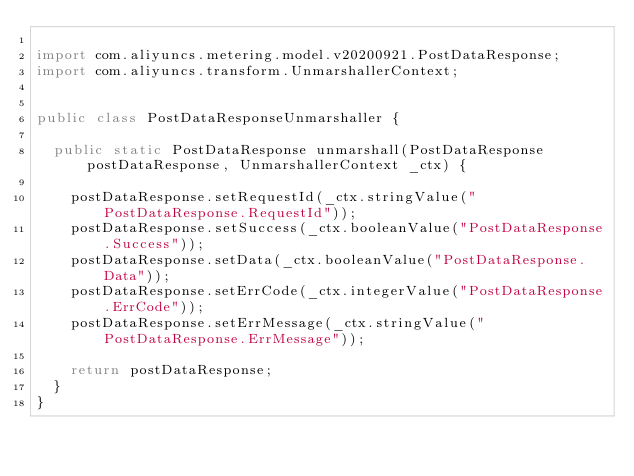Convert code to text. <code><loc_0><loc_0><loc_500><loc_500><_Java_>
import com.aliyuncs.metering.model.v20200921.PostDataResponse;
import com.aliyuncs.transform.UnmarshallerContext;


public class PostDataResponseUnmarshaller {

	public static PostDataResponse unmarshall(PostDataResponse postDataResponse, UnmarshallerContext _ctx) {
		
		postDataResponse.setRequestId(_ctx.stringValue("PostDataResponse.RequestId"));
		postDataResponse.setSuccess(_ctx.booleanValue("PostDataResponse.Success"));
		postDataResponse.setData(_ctx.booleanValue("PostDataResponse.Data"));
		postDataResponse.setErrCode(_ctx.integerValue("PostDataResponse.ErrCode"));
		postDataResponse.setErrMessage(_ctx.stringValue("PostDataResponse.ErrMessage"));
	 
	 	return postDataResponse;
	}
}</code> 